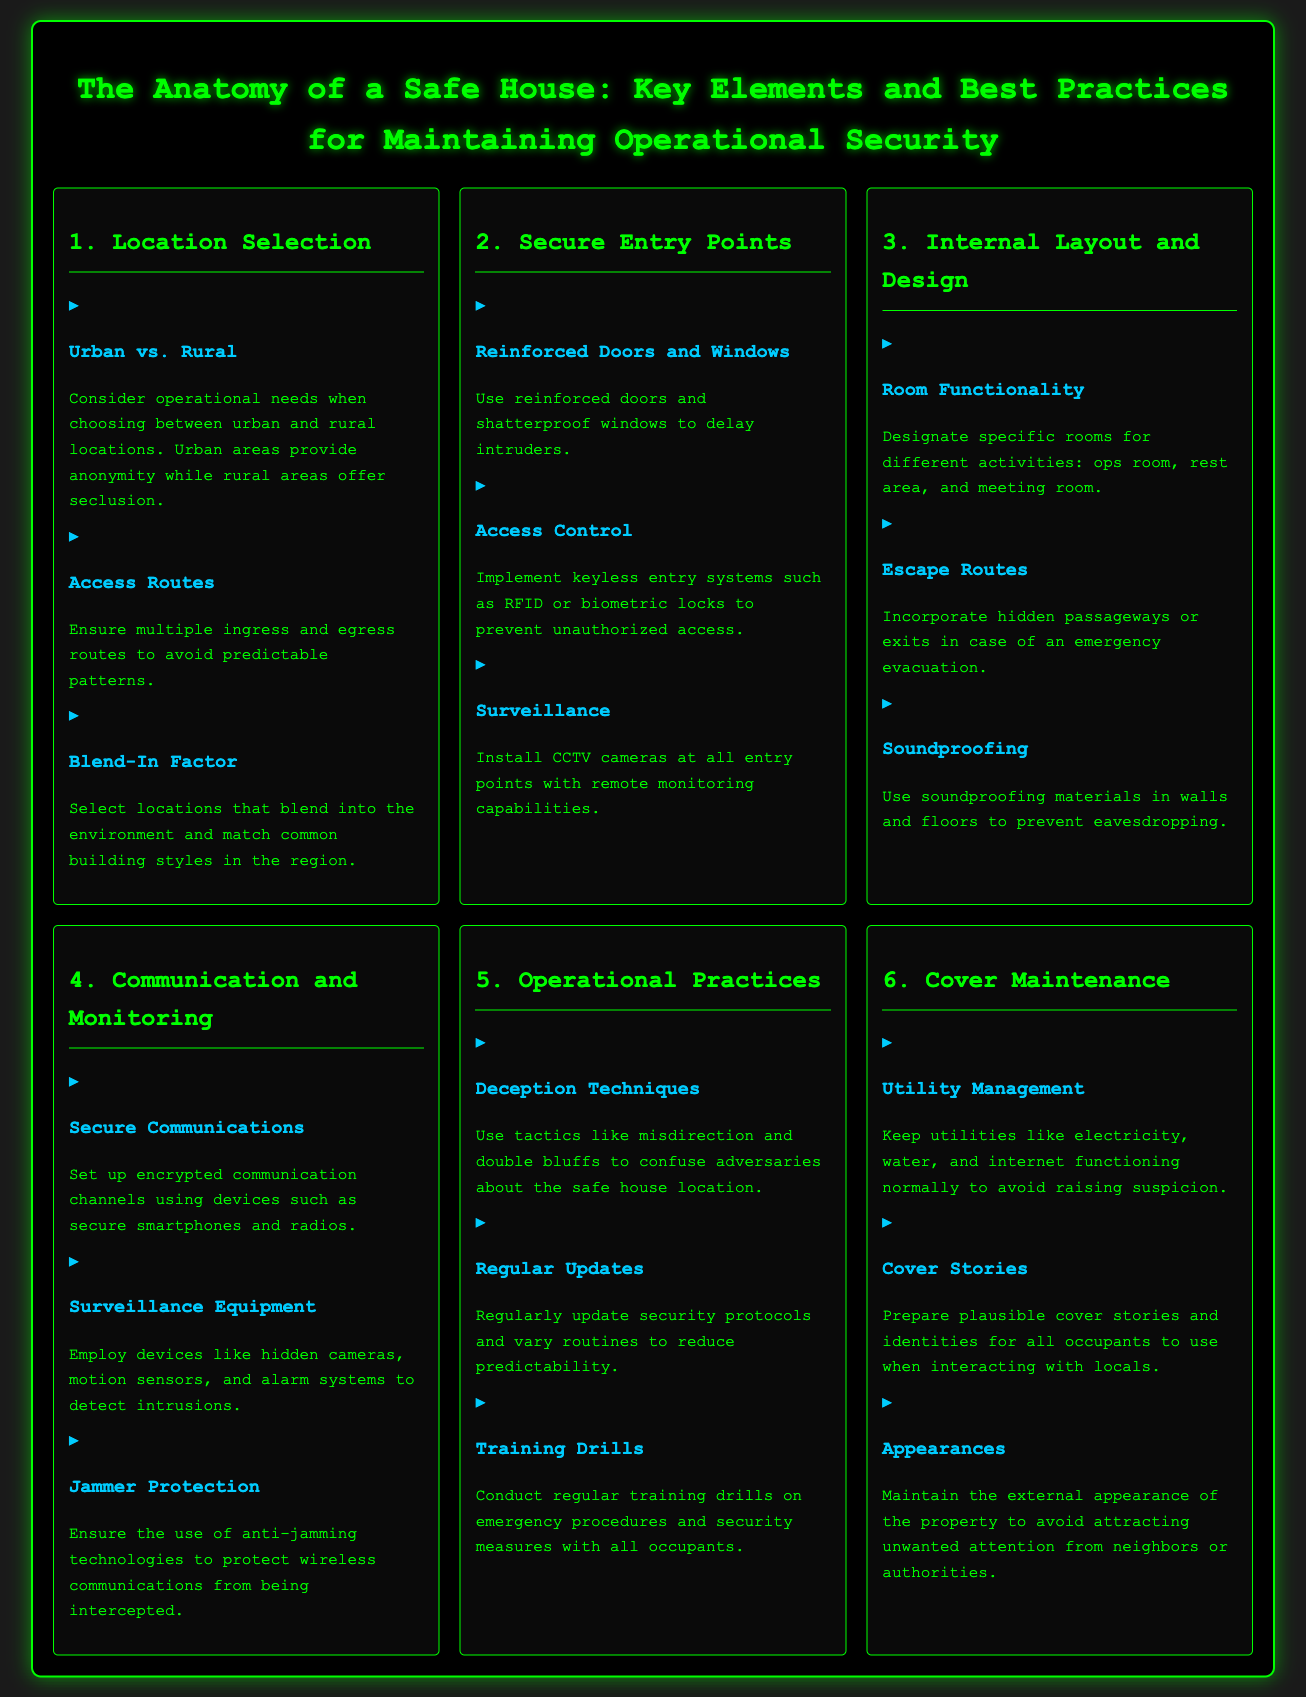what are the key considerations for location selection? The key considerations for location selection in the document include urban versus rural settings, access routes, and blend-in factor.
Answer: urban vs. rural, access routes, blend-in factor what type of doors and windows should be used for secure entry points? The document states that reinforced doors and shatterproof windows should be used to delay intruders.
Answer: reinforced doors and shatterproof windows what room types are recommended for a safe house? The document suggests designating rooms for different activities including ops room, rest area, and meeting room.
Answer: ops room, rest area, meeting room which technology helps protect wireless communications? The document mentions using anti-jamming technologies to protect against wireless interception.
Answer: anti-jamming technologies what is one deception technique mentioned for operational practices? The document suggests using misdirection as a deception technique to confuse adversaries about the safe house location.
Answer: misdirection how should utilities be maintained in a safe house? The document emphasizes that utilities like electricity and water should function normally to avoid raising suspicion.
Answer: normally what is essential for secure communication in a safe house? The document indicates that setting up encrypted communication channels is essential for secure communication.
Answer: encrypted communication channels how often should security protocols be updated? The document implies that security protocols should be regularly updated to reduce predictability.
Answer: regularly what should be maintained to avoid attracting attention? The document highlights that the external appearance of the property should be maintained to avoid attracting unwanted attention.
Answer: external appearance 